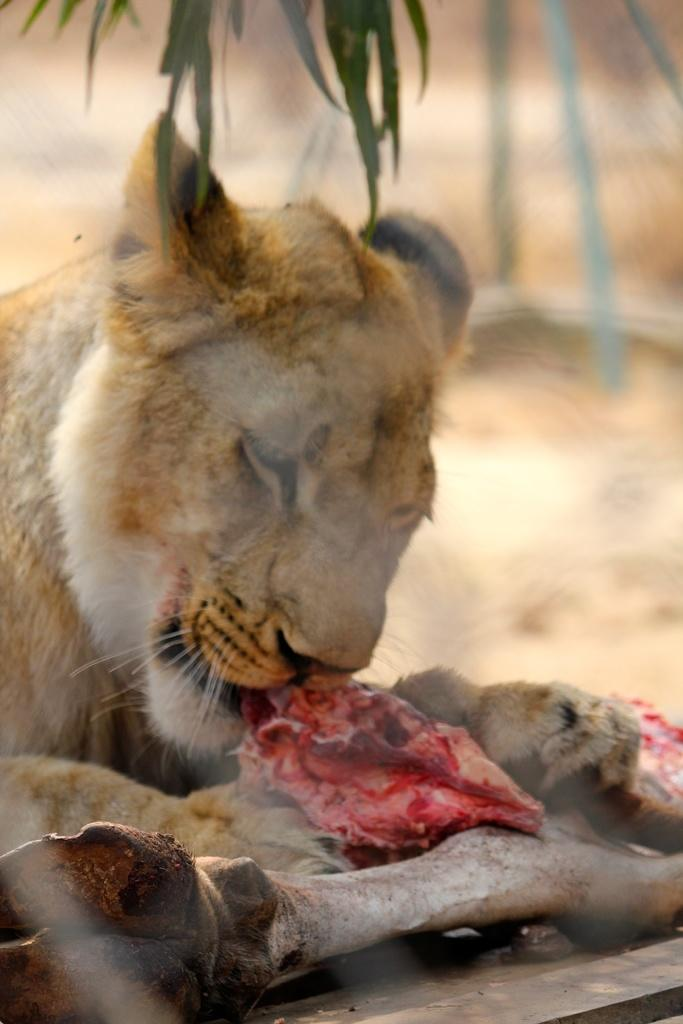What type of animal can be seen in the image? There is a wild animal in the image. Where is the animal located? The animal is on the ground. What is the animal doing in the image? The animal is eating meat. What type of vegetation is present in the image? There are leaves in the image. How would you describe the background of the image? The background appears blurry. How many trucks can be seen in the image? There are no trucks present in the image. How long does it take for the animal to rest in the image? The image does not show the animal resting, and therefore it is not possible to determine how long it takes for the animal to rest. 